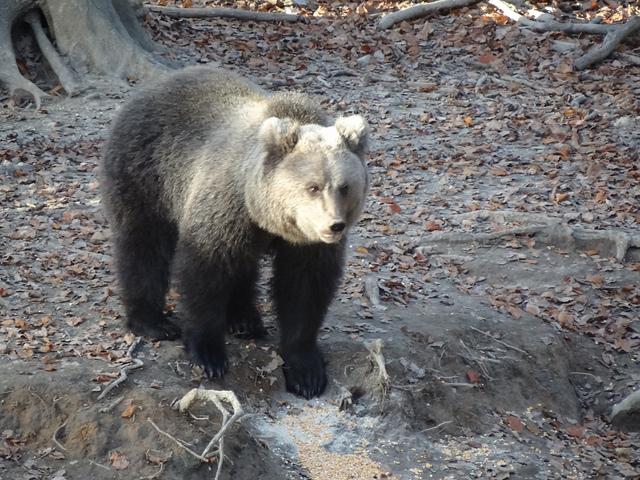Is there any snow on the ground?
Be succinct. No. Is the bear crossing the road?
Be succinct. No. Is this animal larger than a cow?
Keep it brief. No. Are these bears fully grown?
Quick response, please. Yes. What animal is this?
Concise answer only. Bear. How many bears are there?
Write a very short answer. 1. Are their leaves on the ground?
Short answer required. Yes. What color is the bear's fur?
Keep it brief. Black. 